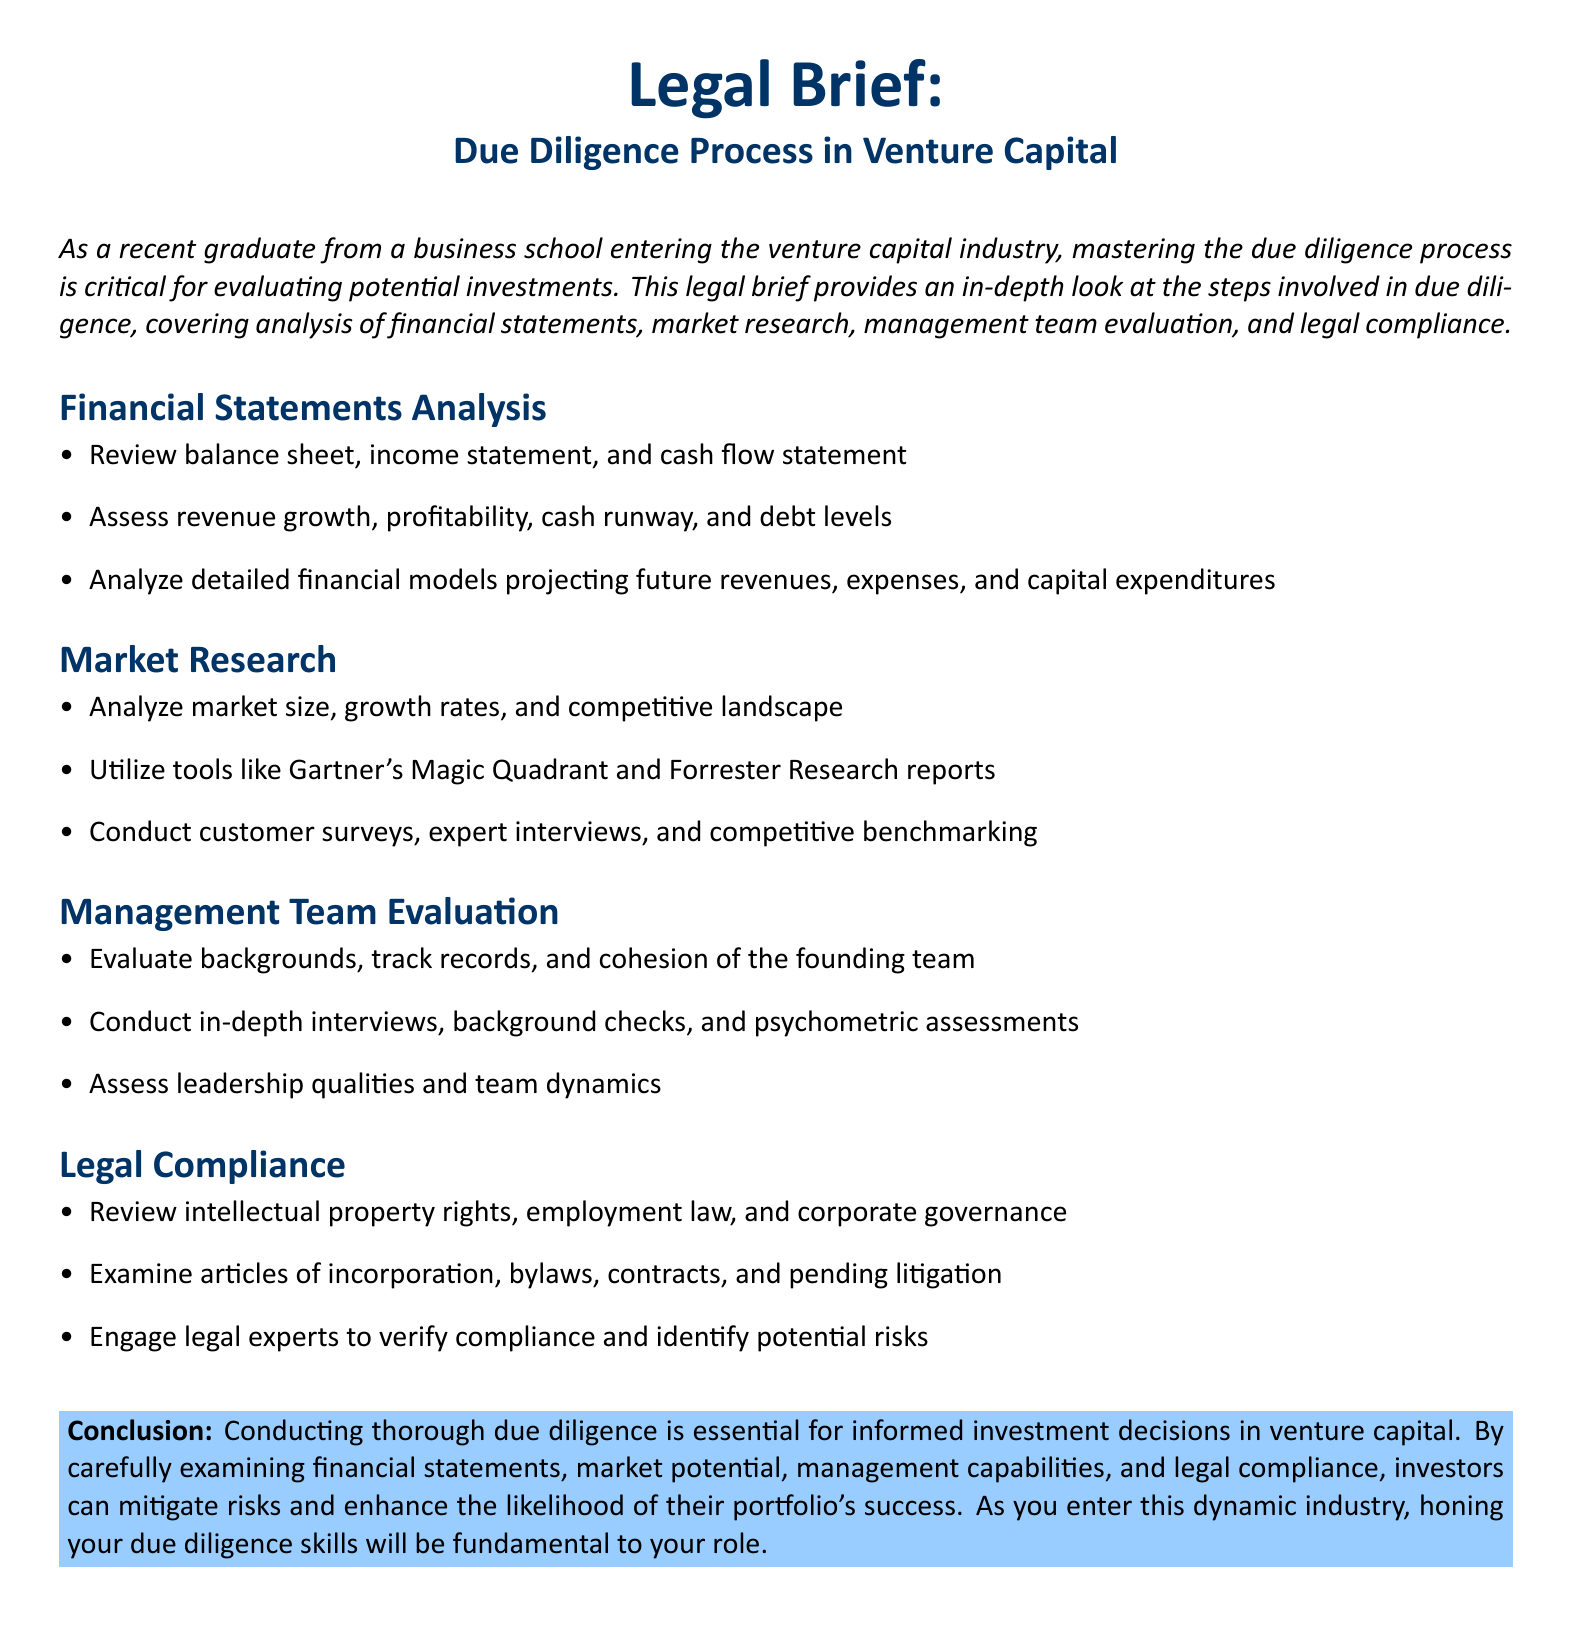What are the three main sections covered in the due diligence process? The document outlines four main sections: Financial Statements Analysis, Market Research, Management Team Evaluation, and Legal Compliance.
Answer: Financial Statements Analysis, Market Research, Management Team Evaluation, Legal Compliance What does the financial statements analysis assess? The financial statements analysis evaluates revenue growth, profitability, cash runway, and debt levels.
Answer: Revenue growth, profitability, cash runway, debt levels Which market analysis tools are mentioned? The document mentions Gartner's Magic Quadrant and Forrester Research reports as tools for market analysis.
Answer: Gartner's Magic Quadrant, Forrester Research reports What is the main purpose of conducting management team evaluations? The management team evaluation aims to assess backgrounds, track records, and cohesion of the founding team.
Answer: Assess backgrounds, track records, and cohesion What is a key focus in the legal compliance section? The legal compliance section focuses on reviewing intellectual property rights, employment law, and corporate governance.
Answer: Intellectual property rights, employment law, corporate governance How many steps are involved in the due diligence process as described in the document? The document explicitly outlines four distinct steps involved in the due diligence process.
Answer: Four What should investors do to mitigate risks according to the conclusion? Investors should conduct thorough due diligence to mitigate risks and enhance portfolio success.
Answer: Conduct thorough due diligence What kind of assessments are included in the management team evaluation? The management team evaluation includes background checks and psychometric assessments.
Answer: Background checks, psychometric assessments 